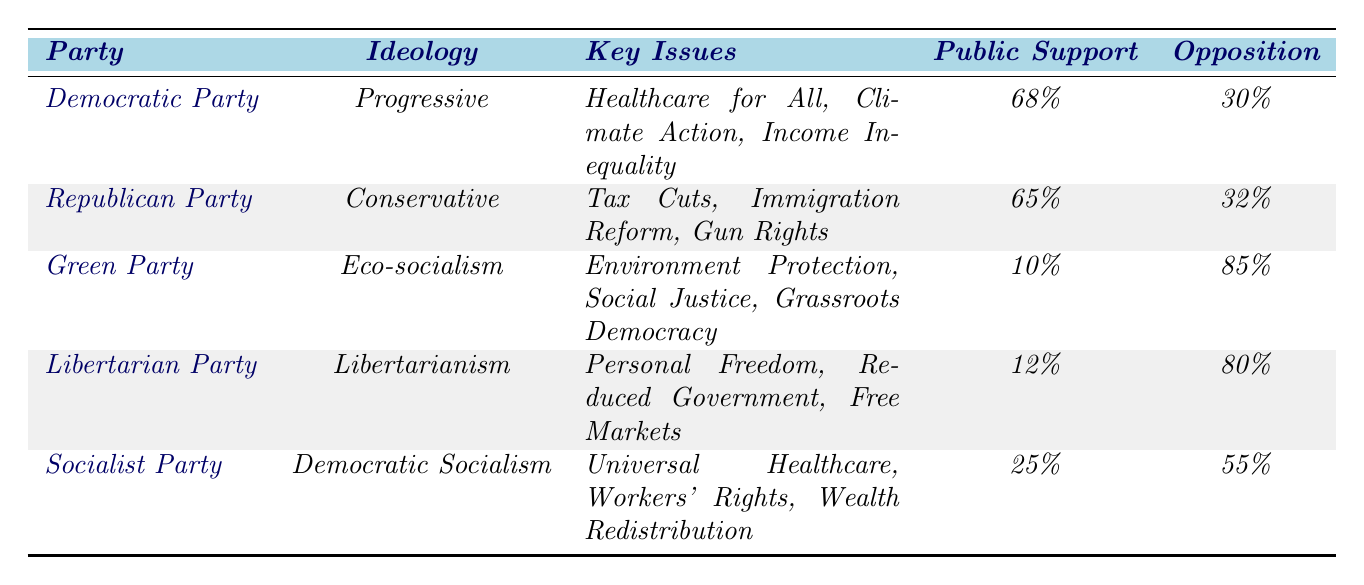What is the public support percentage for the Democratic Party? According to the table, the public support percentage for the Democratic Party is listed as 68%.
Answer: 68% Which party has the least public support? The Green Party has the least public support, which is noted as 10%.
Answer: Green Party What are the key issues for the Republican Party? The key issues for the Republican Party are Tax Cuts, Immigration Reform, and Gun Rights, as stated in the table.
Answer: Tax Cuts, Immigration Reform, Gun Rights How much opposition does the Socialist Party face? The table indicates that the Socialist Party faces 55% opposition.
Answer: 55% Is the public support for the Libertarian Party higher than that for the Green Party? Yes, the public support for the Libertarian Party is 12%, which is higher than the Green Party's public support of 10%.
Answer: Yes What is the difference in public support between the Democratic Party and the Republican Party? To find the difference, subtract the Republican Party's public support (65%) from the Democratic Party's public support (68%): 68% - 65% = 3%.
Answer: 3% Which ideology has the highest public support? The table shows that the Progressive ideology of the Democratic Party has the highest public support at 68%.
Answer: Progressive If you combine the public support of the Libertarian and Green Parties, is it more than that of the Democratic Party? The combined public support of the Libertarian Party (12%) and the Green Party (10%) totals 22%, which is less than the Democratic Party's public support of 68%.
Answer: No What percentage of the public opposes the Green Party? The table indicates that the Green Party faces 85% opposition.
Answer: 85% Which party has a progressive ideology and what are its key issues? The Democratic Party has a progressive ideology, and its key issues are Healthcare for All, Climate Action, and Income Inequality as mentioned in the table.
Answer: Democratic Party; Healthcare for All, Climate Action, Income Inequality What ideology has the lowest public support and what is that percentage? The ideology with the lowest public support is Eco-socialism, associated with the Green Party, with support at 10%.
Answer: Eco-socialism; 10% 